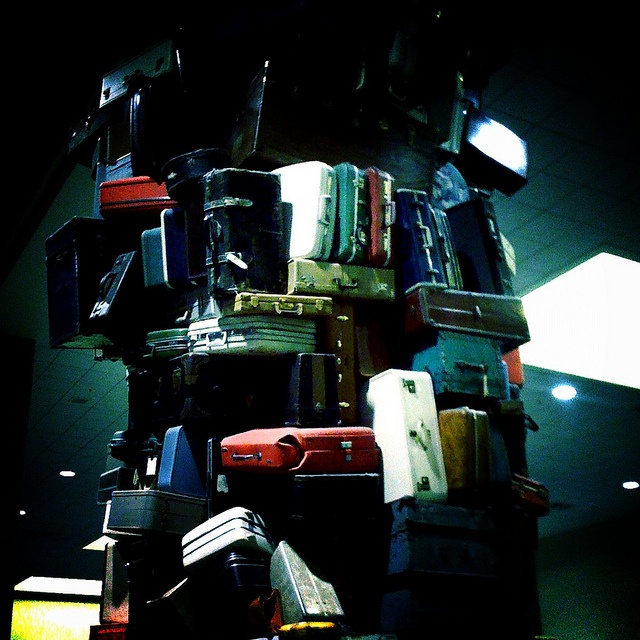Describe the objects in this image and their specific colors. I can see suitcase in black, white, teal, and navy tones, suitcase in black, teal, navy, and white tones, suitcase in black, ivory, darkgray, and beige tones, suitcase in black, maroon, brown, and pink tones, and suitcase in black, white, and teal tones in this image. 